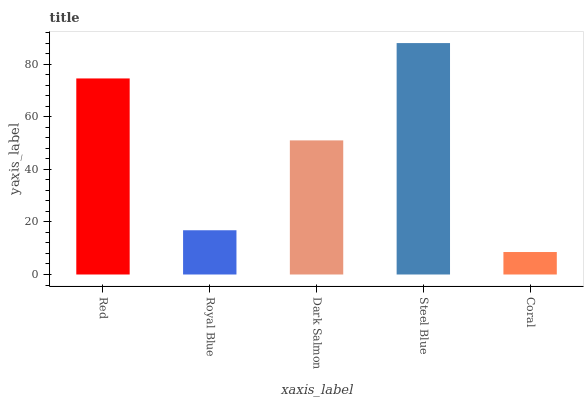Is Coral the minimum?
Answer yes or no. Yes. Is Steel Blue the maximum?
Answer yes or no. Yes. Is Royal Blue the minimum?
Answer yes or no. No. Is Royal Blue the maximum?
Answer yes or no. No. Is Red greater than Royal Blue?
Answer yes or no. Yes. Is Royal Blue less than Red?
Answer yes or no. Yes. Is Royal Blue greater than Red?
Answer yes or no. No. Is Red less than Royal Blue?
Answer yes or no. No. Is Dark Salmon the high median?
Answer yes or no. Yes. Is Dark Salmon the low median?
Answer yes or no. Yes. Is Steel Blue the high median?
Answer yes or no. No. Is Red the low median?
Answer yes or no. No. 